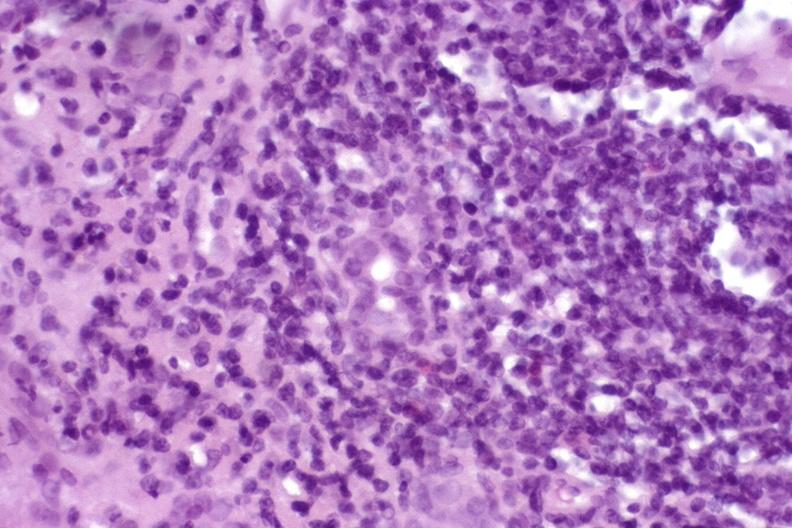s adenoma present?
Answer the question using a single word or phrase. No 